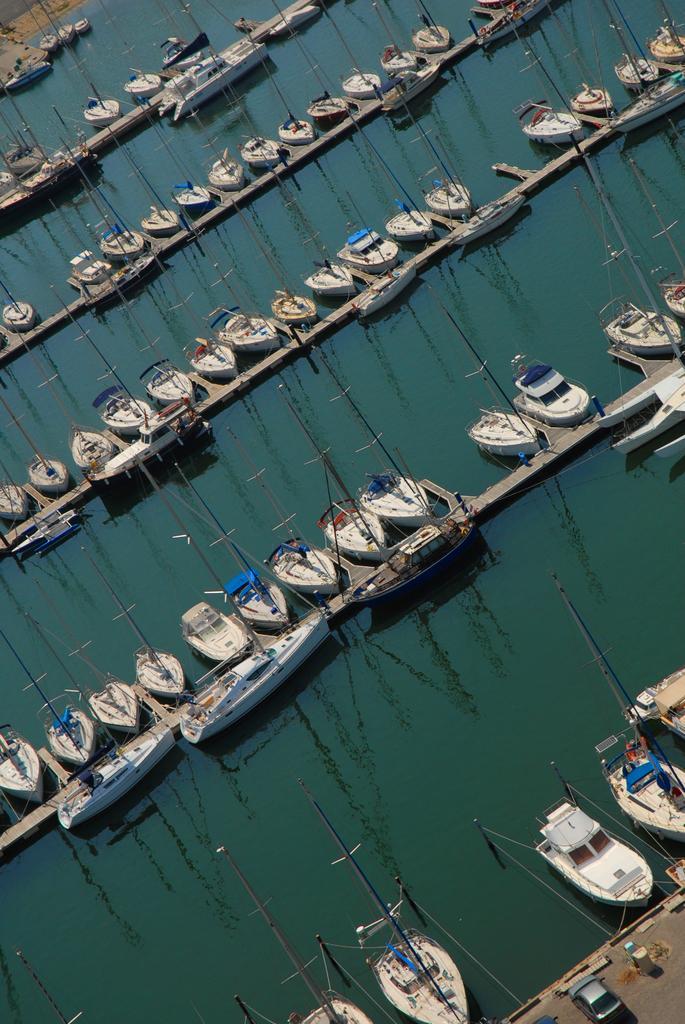Can you describe this image briefly? In this picture we can see boats above the water, bridges, poles and car. 